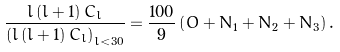<formula> <loc_0><loc_0><loc_500><loc_500>\frac { l \left ( l + 1 \right ) C _ { l } } { \left ( l \left ( l + 1 \right ) C _ { l } \right ) _ { l < 3 0 } } = \frac { 1 0 0 } { 9 } \left ( O + N _ { 1 } + N _ { 2 } + N _ { 3 } \right ) .</formula> 